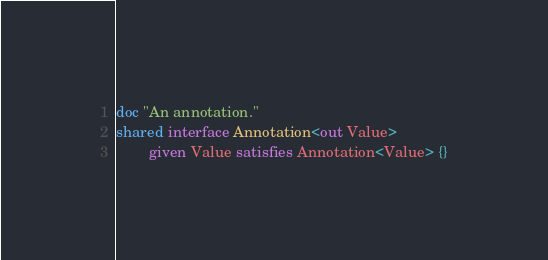Convert code to text. <code><loc_0><loc_0><loc_500><loc_500><_Ceylon_>doc "An annotation."
shared interface Annotation<out Value> 
        given Value satisfies Annotation<Value> {}
</code> 